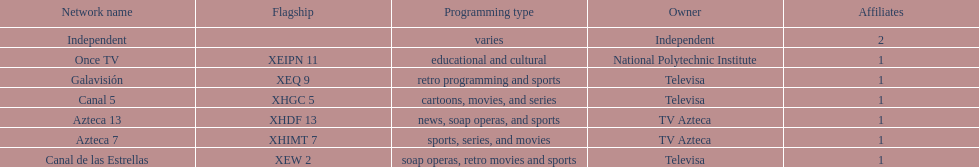How many networks are under tv azteca's ownership? 2. 